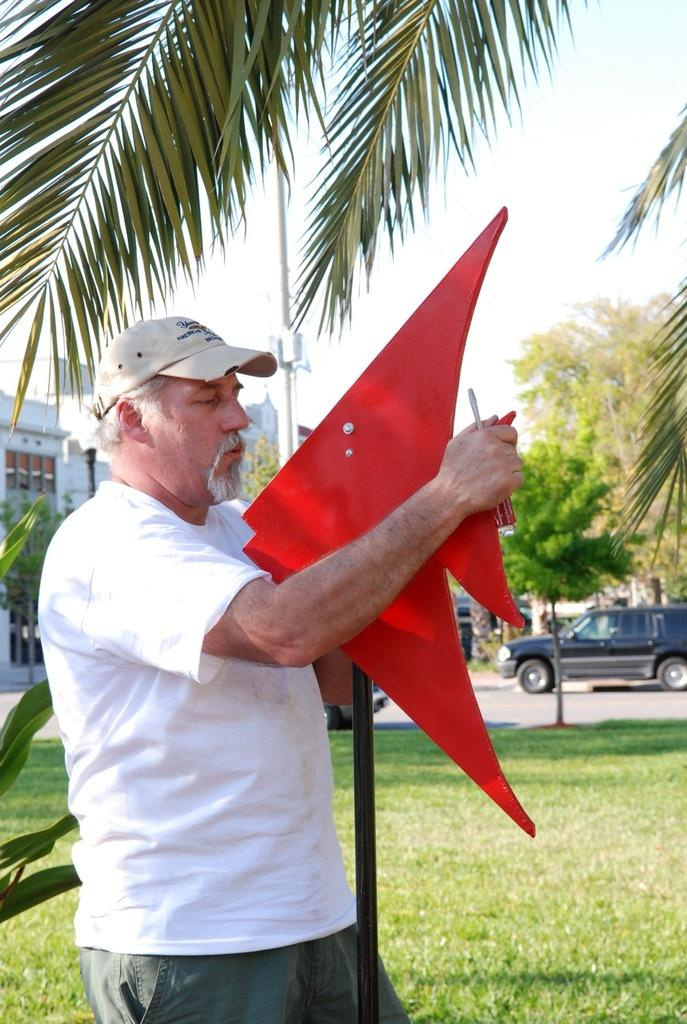What type of vegetation can be seen in the image? There are plants and trees in the image. What type of structure is present in the image? There is a building in the image. What is supporting the wires or cables in the image? There is a pole in the image. What is the condition of the sky in the image? The sky is clear in the image. What type of education is being taught at the school in the image? There is no school present in the image, so it is not possible to determine what type of education is being taught. How many train tracks can be seen in the image? There are no train tracks present in the image. 